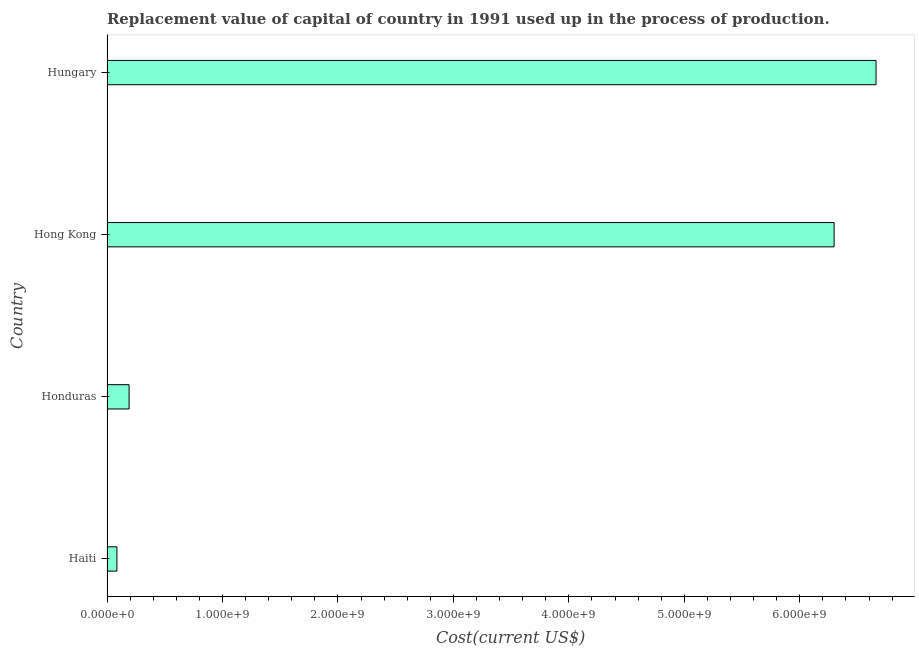Does the graph contain any zero values?
Your answer should be compact. No. What is the title of the graph?
Your answer should be compact. Replacement value of capital of country in 1991 used up in the process of production. What is the label or title of the X-axis?
Your answer should be compact. Cost(current US$). What is the label or title of the Y-axis?
Ensure brevity in your answer.  Country. What is the consumption of fixed capital in Honduras?
Give a very brief answer. 1.92e+08. Across all countries, what is the maximum consumption of fixed capital?
Your answer should be very brief. 6.66e+09. Across all countries, what is the minimum consumption of fixed capital?
Give a very brief answer. 8.59e+07. In which country was the consumption of fixed capital maximum?
Your answer should be very brief. Hungary. In which country was the consumption of fixed capital minimum?
Your answer should be compact. Haiti. What is the sum of the consumption of fixed capital?
Provide a short and direct response. 1.32e+1. What is the difference between the consumption of fixed capital in Honduras and Hungary?
Your answer should be compact. -6.47e+09. What is the average consumption of fixed capital per country?
Provide a short and direct response. 3.31e+09. What is the median consumption of fixed capital?
Provide a short and direct response. 3.24e+09. In how many countries, is the consumption of fixed capital greater than 2200000000 US$?
Ensure brevity in your answer.  2. What is the ratio of the consumption of fixed capital in Haiti to that in Hong Kong?
Give a very brief answer. 0.01. What is the difference between the highest and the second highest consumption of fixed capital?
Provide a succinct answer. 3.63e+08. Is the sum of the consumption of fixed capital in Haiti and Hungary greater than the maximum consumption of fixed capital across all countries?
Give a very brief answer. Yes. What is the difference between the highest and the lowest consumption of fixed capital?
Ensure brevity in your answer.  6.58e+09. In how many countries, is the consumption of fixed capital greater than the average consumption of fixed capital taken over all countries?
Your answer should be very brief. 2. How many bars are there?
Offer a terse response. 4. Are all the bars in the graph horizontal?
Your answer should be very brief. Yes. How many countries are there in the graph?
Keep it short and to the point. 4. What is the difference between two consecutive major ticks on the X-axis?
Ensure brevity in your answer.  1.00e+09. Are the values on the major ticks of X-axis written in scientific E-notation?
Provide a short and direct response. Yes. What is the Cost(current US$) of Haiti?
Offer a terse response. 8.59e+07. What is the Cost(current US$) of Honduras?
Keep it short and to the point. 1.92e+08. What is the Cost(current US$) in Hong Kong?
Offer a very short reply. 6.30e+09. What is the Cost(current US$) of Hungary?
Give a very brief answer. 6.66e+09. What is the difference between the Cost(current US$) in Haiti and Honduras?
Offer a terse response. -1.06e+08. What is the difference between the Cost(current US$) in Haiti and Hong Kong?
Make the answer very short. -6.21e+09. What is the difference between the Cost(current US$) in Haiti and Hungary?
Ensure brevity in your answer.  -6.58e+09. What is the difference between the Cost(current US$) in Honduras and Hong Kong?
Provide a short and direct response. -6.11e+09. What is the difference between the Cost(current US$) in Honduras and Hungary?
Keep it short and to the point. -6.47e+09. What is the difference between the Cost(current US$) in Hong Kong and Hungary?
Provide a succinct answer. -3.63e+08. What is the ratio of the Cost(current US$) in Haiti to that in Honduras?
Provide a short and direct response. 0.45. What is the ratio of the Cost(current US$) in Haiti to that in Hong Kong?
Your answer should be very brief. 0.01. What is the ratio of the Cost(current US$) in Haiti to that in Hungary?
Provide a short and direct response. 0.01. What is the ratio of the Cost(current US$) in Honduras to that in Hungary?
Provide a succinct answer. 0.03. What is the ratio of the Cost(current US$) in Hong Kong to that in Hungary?
Provide a succinct answer. 0.94. 